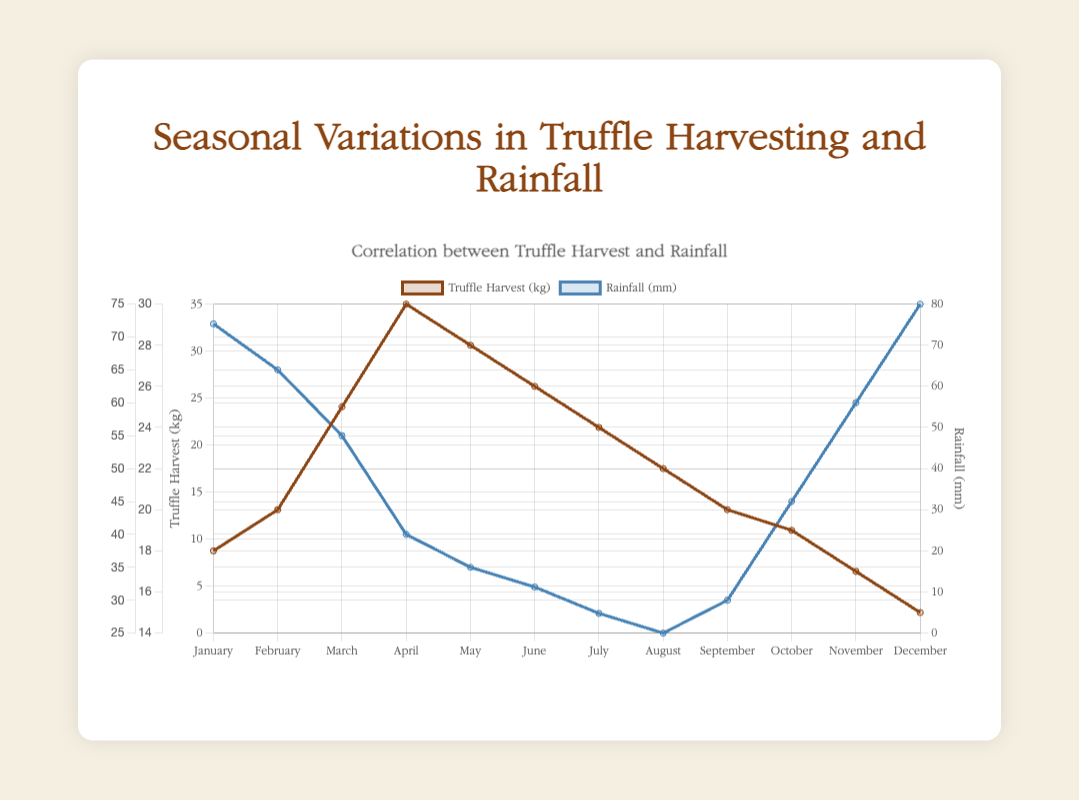What is the month with the highest truffle harvest? The month with the highest truffle harvest has the tallest line peak for the truffle harvest dataset. In this figure, that peak occurs in April.
Answer: April Which month has the lowest rainfall and what is the corresponding truffle harvest? The lowest rainfall occurs where the rainfall line is at its lowest point. This point is in August. The truffle harvest for August is 22 kg.
Answer: August, 22 kg Compare the truffle harvests in June and December. Which one is higher and by how much? From the figure, June has a truffle harvest of 26 kg and December has 15 kg. The difference between them is 26 - 15 = 11 kg.
Answer: June, 11 kg What is the total rainfall in the first quarter of the year (January to March)? Sum the rainfall values for January, February, and March: 72 + 65 + 55 = 192 mm.
Answer: 192 mm How does the truffle harvest in May compare to that in October? The truffle harvest in May is 28 kg and in October is 19 kg. May's harvest is greater by 28 - 19 = 9 kg.
Answer: May, 9 kg In which month(s) does the truffle harvest exactly match the rainfall? Checking both datasets, the truffle harvest and rainfall amounts are equal in April, where both are at 30 units.
Answer: April What is the average truffle harvest from July to September? Sum the values from July, August, and September, and then divide by the number of months: (24 + 22 + 20) / 3 = 66 / 3 = 22 kg.
Answer: 22 kg Which season (group three months at a time) shows the most significant decrease in rainfall from one month to the next? Jan-Mar: (72, 65, 55), Apr-Jun: (40, 35, 32), Jul-Sep: (28, 25, 30), Oct-Dec: (45, 60, 75). The most significant single month to month decrease occurs in Jan-Mar; from January to February rainfall decreases 72 - 65 = 7 mm.
Answer: January to February Is there a noticeable correlation between high truffle harvest and low rainfall? The figure shows the highest truffle harvests occur in months with lower rainfall; particularly from April to June, where lower rain corresponds to higher truffle harvest.
Answer: Yes 